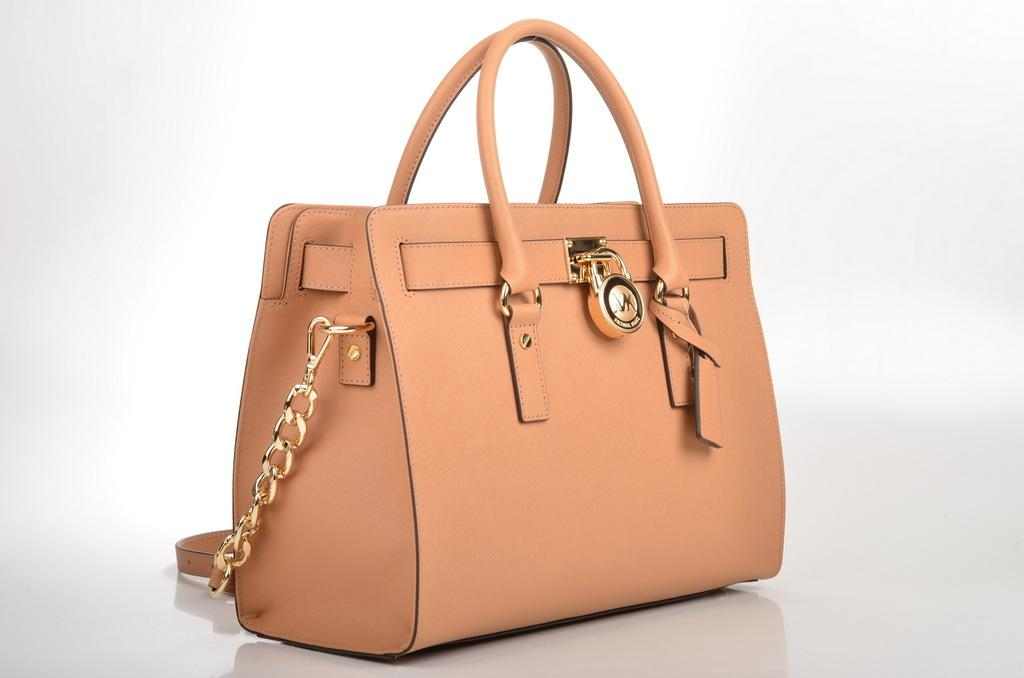What object is present in the image that can be used to carry items? There is a bag in the image that can be used to carry items. What feature does the bag have to secure its contents? The bag has a lock to secure its contents. How is the bag attached to the user's body? The bag has straps that can be used to attach it to the user's body. Where is the bag located in the image? The bag is placed on the floor in the image. What type of canvas is visible in the image? There is no canvas present in the image. How many people are in the group that is holding the mailbox in the image? There is no group or mailbox present in the image. 